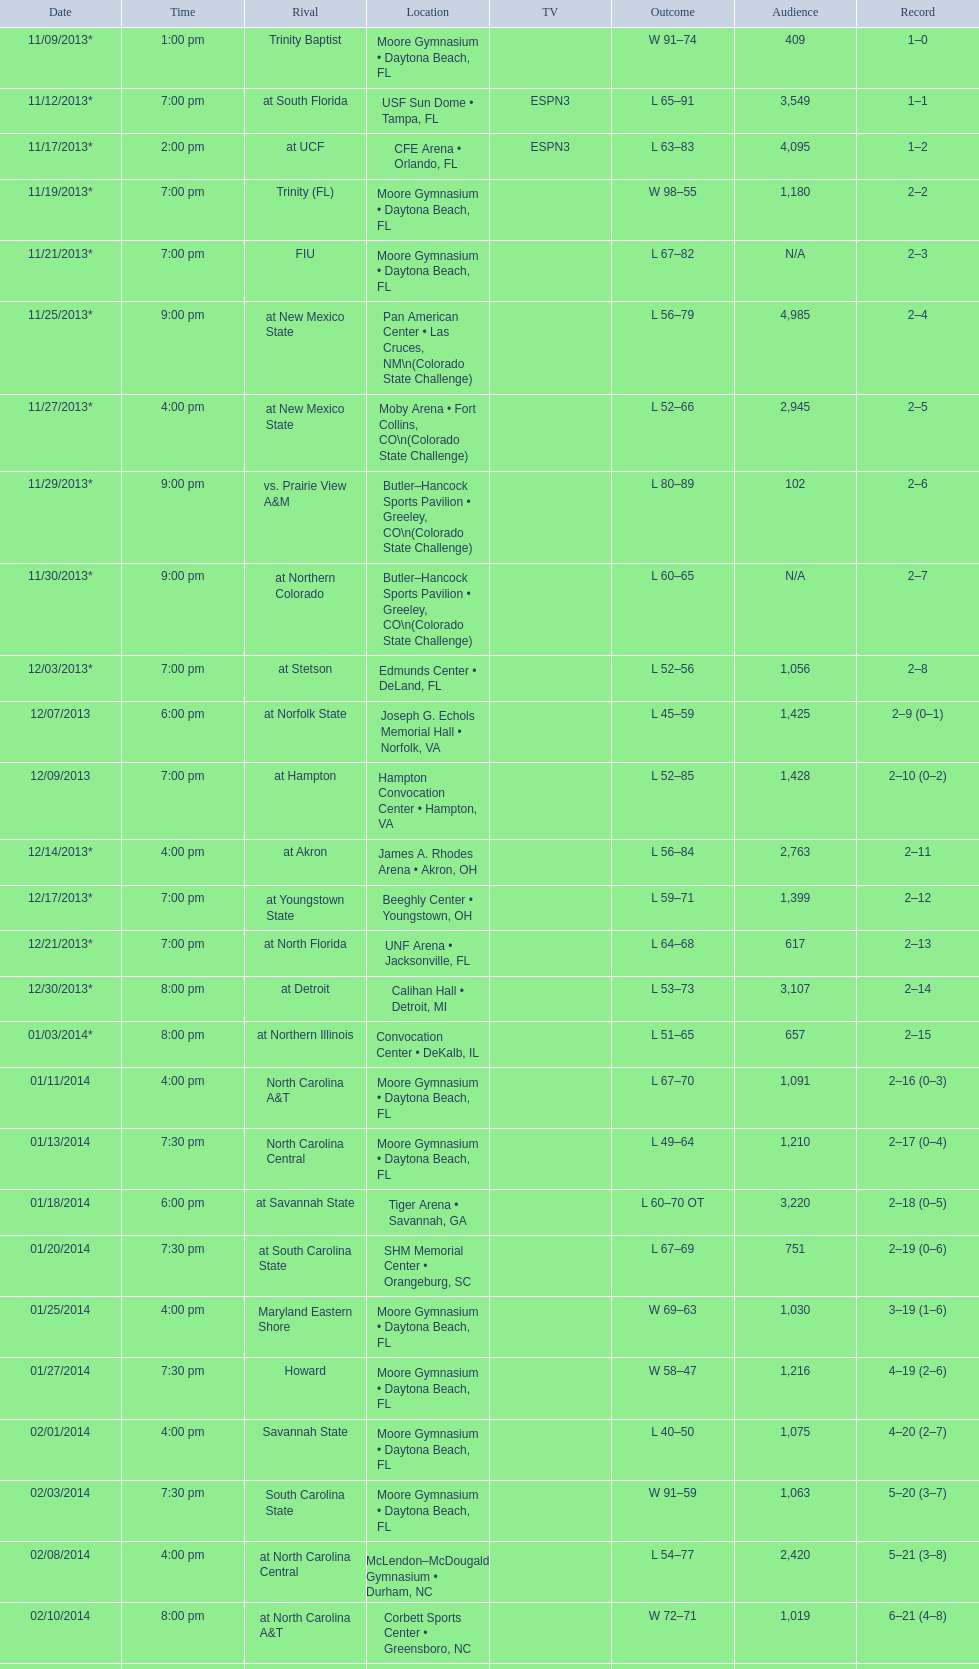How many games did the wildcats play in daytona beach, fl? 11. 